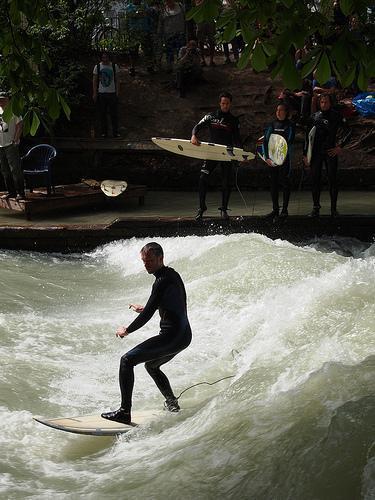How many people watching the man surf?
Give a very brief answer. 3. How many men are surfing?
Give a very brief answer. 1. How many chairs?
Give a very brief answer. 1. How many people in white shirts?
Give a very brief answer. 2. How many women holding surfboards?
Give a very brief answer. 1. How many surfboards laying down on the deck?
Give a very brief answer. 1. How many people are waiting to surf on the sideline?
Give a very brief answer. 3. 